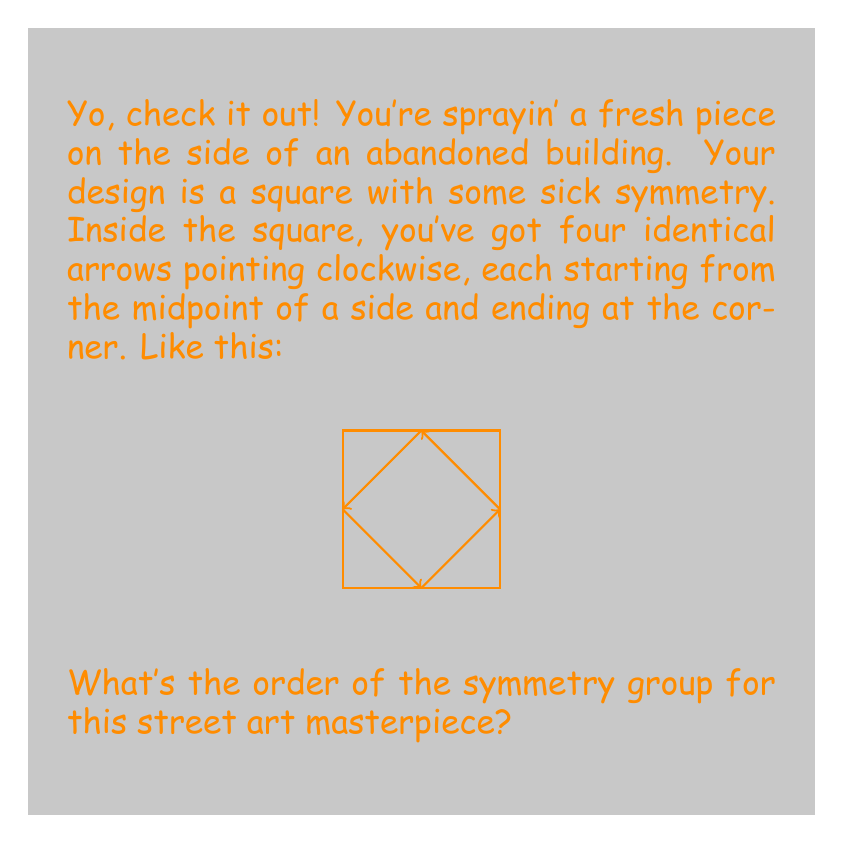Give your solution to this math problem. Aight, let's break this down step by step:

1) First, we gotta identify all the symmetries of this design. We're looking for rotations and reflections that leave the design unchanged.

2) Rotations:
   - 90° clockwise (quarter turn)
   - 180° (half turn)
   - 270° clockwise (three-quarter turn)
   - 360° (full turn, same as doing nothing)

3) Reflections:
   - Across the vertical line through the center
   - Across the horizontal line through the center
   - Across the diagonal from top-left to bottom-right
   - Across the diagonal from top-right to bottom-left

4) Now, let's count these symmetries:
   - 4 rotations (including the identity, which is a 360° rotation)
   - 4 reflections

5) The total number of symmetries is 4 + 4 = 8

6) In group theory, the number of elements in a group is called its order.

7) So, the order of the symmetry group for this graffiti design is 8.

8) For the math heads out there, this group is known as $D_4$ (the dihedral group of order 8), or sometimes $D_8$ depending on the notation used.
Answer: 8 